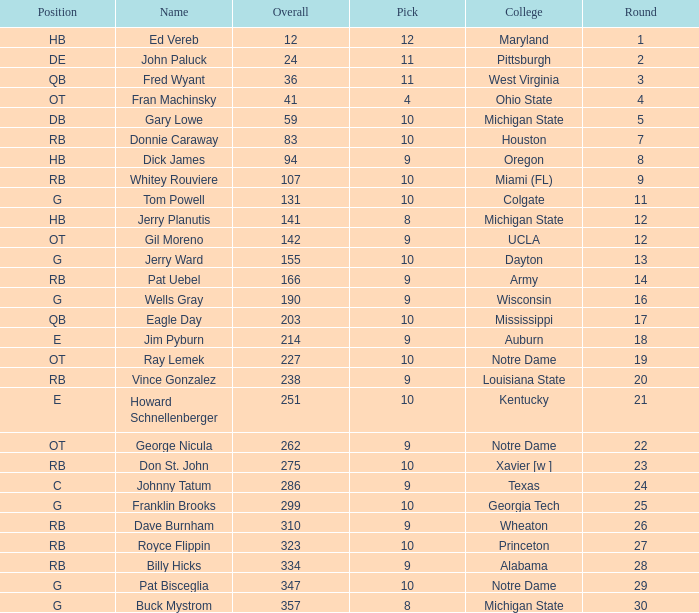What is the sum of rounds that has a pick of 9 and is named jim pyburn? 18.0. 